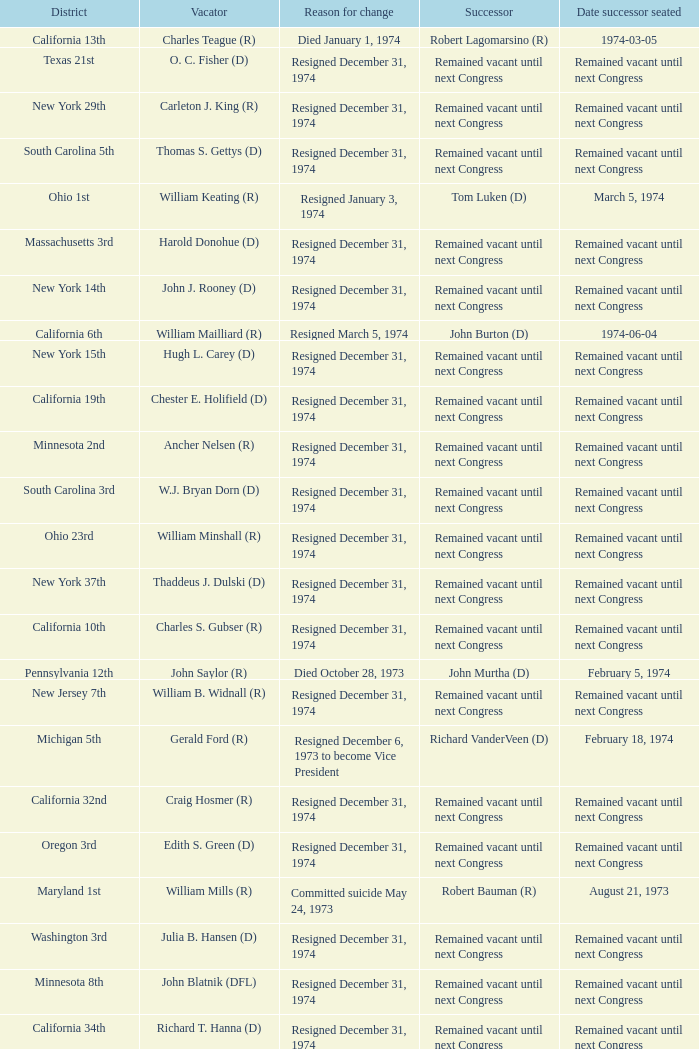When was the date successor installed when the vacator was charles e. chamberlain (r)? Remained vacant until next Congress. 